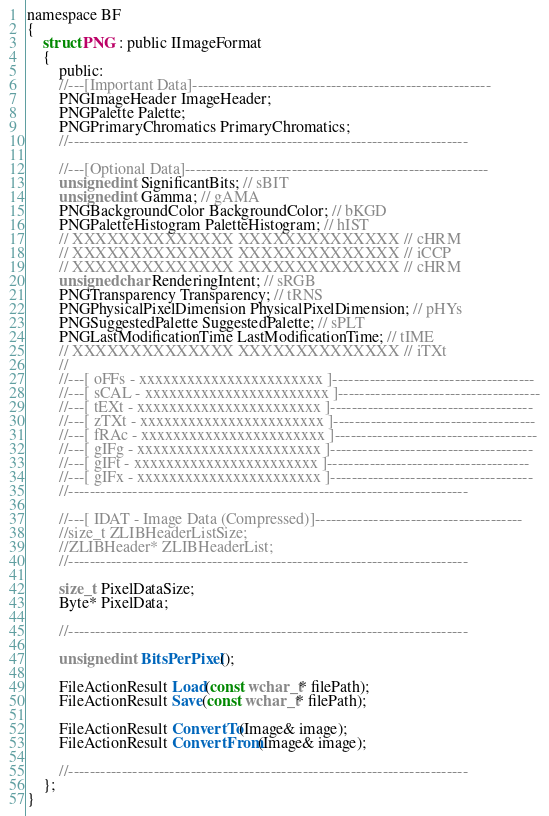<code> <loc_0><loc_0><loc_500><loc_500><_C_>namespace BF
{
	struct PNG : public IImageFormat
	{
		public:
		//---[Important Data]--------------------------------------------------------
		PNGImageHeader ImageHeader; 
		PNGPalette Palette;
		PNGPrimaryChromatics PrimaryChromatics;
		//---------------------------------------------------------------------------

		//---[Optional Data]---------------------------------------------------------
		unsigned int SignificantBits; // sBIT
		unsigned int Gamma; // gAMA
		PNGBackgroundColor BackgroundColor; // bKGD
		PNGPaletteHistogram PaletteHistogram; // hIST
		// XXXXXXXXXXXXXX XXXXXXXXXXXXXX // cHRM
		// XXXXXXXXXXXXXX XXXXXXXXXXXXXX // iCCP
		// XXXXXXXXXXXXXX XXXXXXXXXXXXXX // cHRM
		unsigned char RenderingIntent; // sRGB
		PNGTransparency Transparency; // tRNS
		PNGPhysicalPixelDimension PhysicalPixelDimension; // pHYs
		PNGSuggestedPalette SuggestedPalette; // sPLT
		PNGLastModificationTime LastModificationTime; // tIME
		// XXXXXXXXXXXXXX XXXXXXXXXXXXXX // iTXt
		// 
		//---[ oFFs - xxxxxxxxxxxxxxxxxxxxxxx ]--------------------------------------
		//---[ sCAL - xxxxxxxxxxxxxxxxxxxxxxx ]--------------------------------------
		//---[ tEXt - xxxxxxxxxxxxxxxxxxxxxxx ]--------------------------------------
		//---[ zTXt - xxxxxxxxxxxxxxxxxxxxxxx ]--------------------------------------
		//---[ fRAc - xxxxxxxxxxxxxxxxxxxxxxx ]--------------------------------------
		//---[ gIFg - xxxxxxxxxxxxxxxxxxxxxxx ]--------------------------------------
		//---[ gIFt - xxxxxxxxxxxxxxxxxxxxxxx ]--------------------------------------
		//---[ gIFx - xxxxxxxxxxxxxxxxxxxxxxx ]--------------------------------------
		//---------------------------------------------------------------------------

		//---[ IDAT - Image Data (Compressed)]---------------------------------------
		//size_t ZLIBHeaderListSize;
		//ZLIBHeader* ZLIBHeaderList;
		//---------------------------------------------------------------------------

		size_t PixelDataSize;
		Byte* PixelData;

		//---------------------------------------------------------------------------

		unsigned int BitsPerPixel();

		FileActionResult Load(const wchar_t* filePath);
		FileActionResult Save(const wchar_t* filePath);

		FileActionResult ConvertTo(Image& image);
		FileActionResult ConvertFrom(Image& image);		

		//---------------------------------------------------------------------------
	};
}</code> 